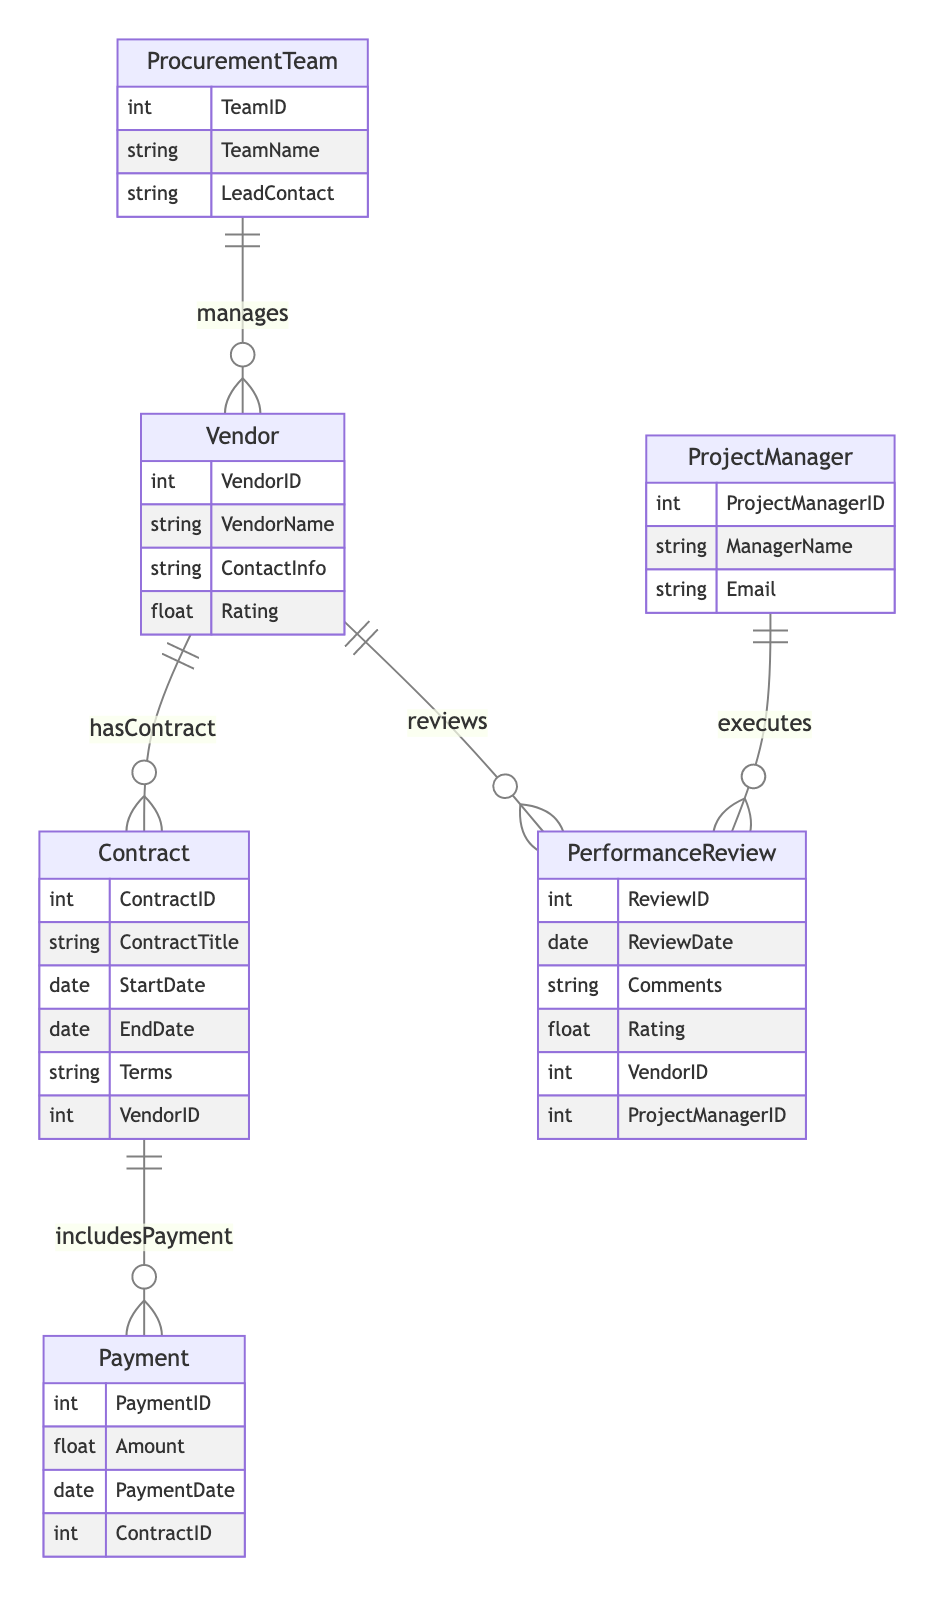What is the primary key of the Vendor entity? The primary key of the Vendor entity is VendorID. This is identified in the diagram as a unique identifier for each vendor.
Answer: VendorID How many entities are present in the diagram? By examining the diagram, there are a total of six entities: Vendor, Contract, ProcurementTeam, ProjectManager, PerformanceReview, and Payment. Adding these provides the total count.
Answer: Six What relationship exists between the Vendor and the Procurement Team? The diagram shows that the relationship is labeled "manages," indicating a one-to-many connection where one procurement team can manage multiple vendors.
Answer: Manages Which entity does the Contract include if it wants to process a payment? The diagram indicates that the Payment entity includes a foreign key to the Contract entity, meaning payments are tied to specific contracts for processing.
Answer: Contract How many Performance Reviews can a single Project Manager execute? The "executes" relationship shows that a single Project Manager can conduct multiple Performance Reviews, suggesting a one-to-many relationship.
Answer: Many Which entity is linked to Performance Review through both Vendor and ProjectManager? The PerformanceReview entity contains foreign keys to both Vendor and ProjectManager, indicating that each review is connected to one vendor and one project manager at the same time.
Answer: PerformanceReview What is the relationship type connecting Vendor to Performance Review? The relationship type between Vendor and Performance Review is 1:N (one-to-many), indicating that a single vendor can be reviewed multiple times through the performance reviews.
Answer: One-to-Many What is the main purpose of the Contract entity in this diagram? The main purpose of the Contract entity is to hold details of agreements made with vendors, including terms and related payments as indicated by its relationships.
Answer: Hold agreements How does the Procurement Team relate to the Vendor? The Procurement Team manages vendors, reflecting a direct management relationship where one team can oversee many vendors.
Answer: Manages 